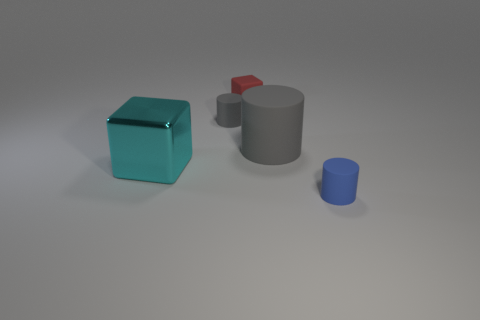Add 2 small yellow metallic cubes. How many objects exist? 7 Subtract all cylinders. How many objects are left? 2 Add 1 tiny green matte balls. How many tiny green matte balls exist? 1 Subtract 0 gray balls. How many objects are left? 5 Subtract all small red cubes. Subtract all large cylinders. How many objects are left? 3 Add 5 big cyan metal objects. How many big cyan metal objects are left? 6 